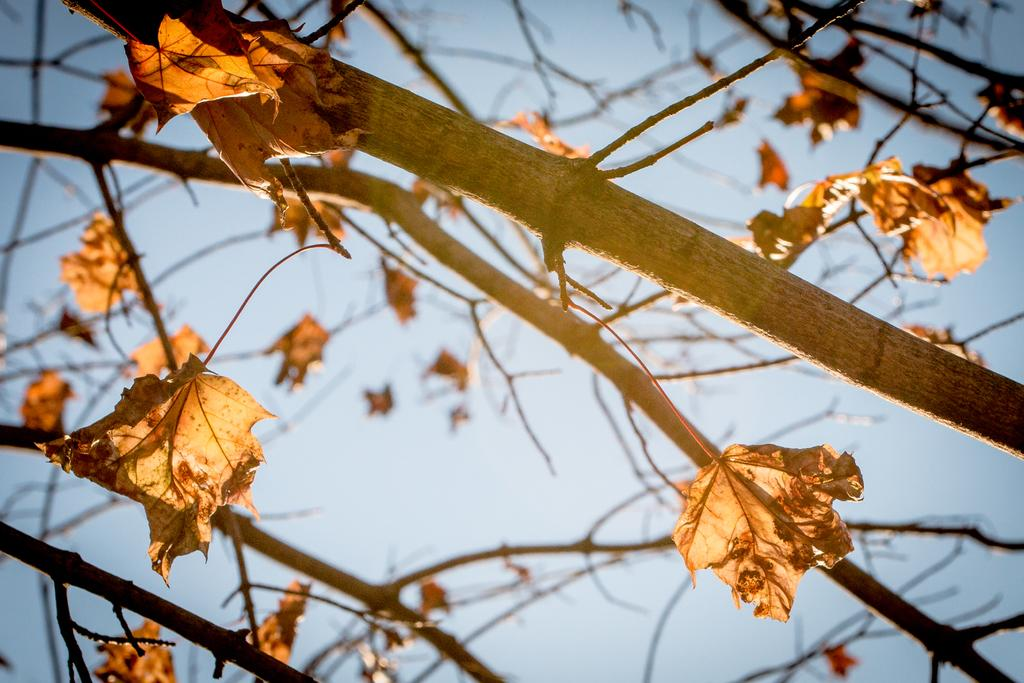What type of vegetation is present in the image? There are branches and leaves of a tree in the image. What part of the natural environment is visible in the image? The sky is visible in the image. How many shirts are hanging on the branches of the tree in the image? There are no shirts present in the image; it only features branches and leaves of a tree. 